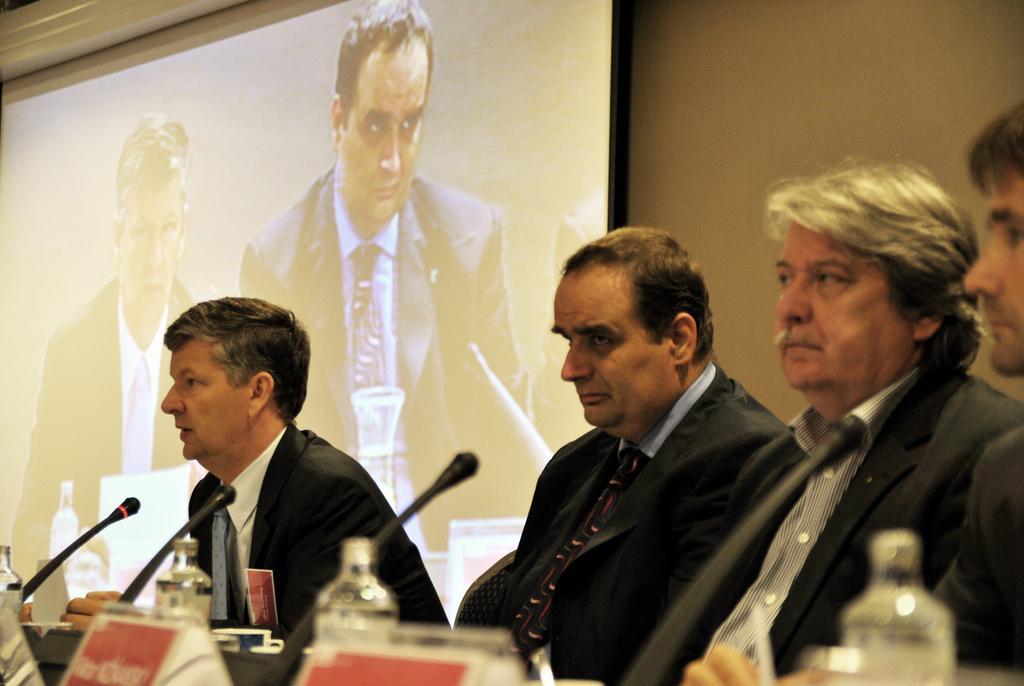Can you describe this image briefly? In this image I can see few men are sitting and I can see all of them are wearing formal dress. I can also see few bottles, few mics, few boards and in the background I can see projector's screen. On this screen I can see two more men and I can see both of them are wearing formal dress. 